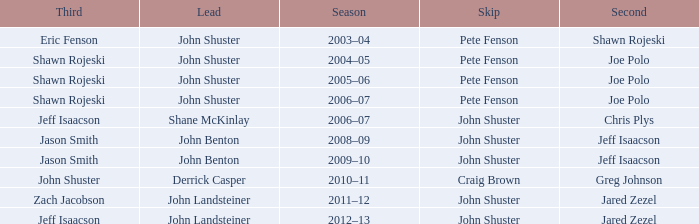Which season has Zach Jacobson in third? 2011–12. 